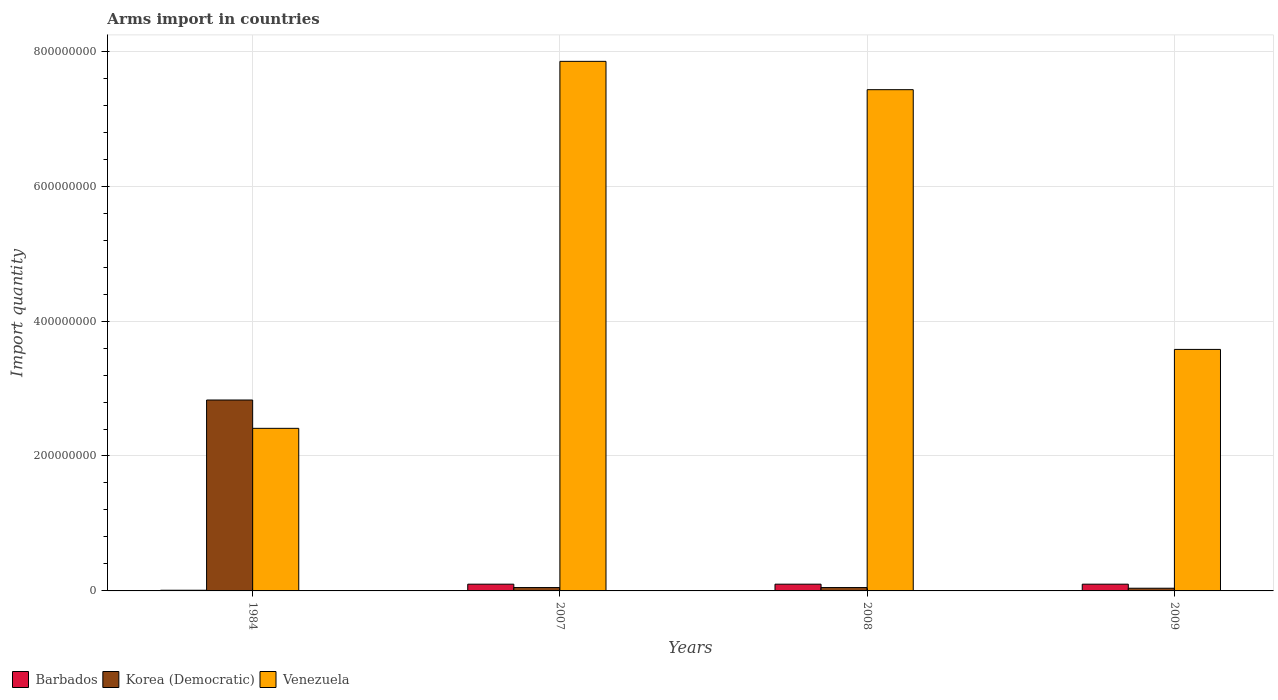Are the number of bars per tick equal to the number of legend labels?
Ensure brevity in your answer.  Yes. Are the number of bars on each tick of the X-axis equal?
Ensure brevity in your answer.  Yes. How many bars are there on the 4th tick from the left?
Your answer should be compact. 3. How many bars are there on the 2nd tick from the right?
Make the answer very short. 3. What is the label of the 2nd group of bars from the left?
Provide a short and direct response. 2007. In how many cases, is the number of bars for a given year not equal to the number of legend labels?
Make the answer very short. 0. What is the total arms import in Venezuela in 2007?
Your response must be concise. 7.85e+08. Across all years, what is the maximum total arms import in Venezuela?
Offer a terse response. 7.85e+08. In which year was the total arms import in Barbados minimum?
Your answer should be compact. 1984. What is the total total arms import in Barbados in the graph?
Give a very brief answer. 3.10e+07. What is the difference between the total arms import in Korea (Democratic) in 2007 and that in 2009?
Offer a very short reply. 1.00e+06. What is the difference between the total arms import in Venezuela in 2007 and the total arms import in Korea (Democratic) in 2009?
Provide a short and direct response. 7.81e+08. What is the average total arms import in Korea (Democratic) per year?
Offer a terse response. 7.42e+07. In the year 2008, what is the difference between the total arms import in Barbados and total arms import in Venezuela?
Keep it short and to the point. -7.33e+08. In how many years, is the total arms import in Barbados greater than 760000000?
Ensure brevity in your answer.  0. What is the ratio of the total arms import in Korea (Democratic) in 1984 to that in 2009?
Your response must be concise. 70.75. Is the total arms import in Barbados in 2008 less than that in 2009?
Ensure brevity in your answer.  No. Is the difference between the total arms import in Barbados in 1984 and 2009 greater than the difference between the total arms import in Venezuela in 1984 and 2009?
Give a very brief answer. Yes. What is the difference between the highest and the second highest total arms import in Venezuela?
Your answer should be very brief. 4.20e+07. What is the difference between the highest and the lowest total arms import in Venezuela?
Your answer should be very brief. 5.44e+08. In how many years, is the total arms import in Venezuela greater than the average total arms import in Venezuela taken over all years?
Your answer should be very brief. 2. Is the sum of the total arms import in Korea (Democratic) in 1984 and 2007 greater than the maximum total arms import in Venezuela across all years?
Your response must be concise. No. What does the 1st bar from the left in 1984 represents?
Provide a succinct answer. Barbados. What does the 2nd bar from the right in 2009 represents?
Your response must be concise. Korea (Democratic). How many bars are there?
Make the answer very short. 12. Are all the bars in the graph horizontal?
Your response must be concise. No. How many years are there in the graph?
Offer a terse response. 4. What is the difference between two consecutive major ticks on the Y-axis?
Your response must be concise. 2.00e+08. Does the graph contain grids?
Provide a succinct answer. Yes. How many legend labels are there?
Provide a succinct answer. 3. How are the legend labels stacked?
Your response must be concise. Horizontal. What is the title of the graph?
Ensure brevity in your answer.  Arms import in countries. What is the label or title of the Y-axis?
Keep it short and to the point. Import quantity. What is the Import quantity of Korea (Democratic) in 1984?
Ensure brevity in your answer.  2.83e+08. What is the Import quantity of Venezuela in 1984?
Your answer should be very brief. 2.41e+08. What is the Import quantity of Barbados in 2007?
Your answer should be very brief. 1.00e+07. What is the Import quantity in Korea (Democratic) in 2007?
Keep it short and to the point. 5.00e+06. What is the Import quantity of Venezuela in 2007?
Your answer should be very brief. 7.85e+08. What is the Import quantity in Barbados in 2008?
Your answer should be very brief. 1.00e+07. What is the Import quantity of Venezuela in 2008?
Your answer should be very brief. 7.43e+08. What is the Import quantity of Venezuela in 2009?
Provide a succinct answer. 3.58e+08. Across all years, what is the maximum Import quantity of Korea (Democratic)?
Ensure brevity in your answer.  2.83e+08. Across all years, what is the maximum Import quantity of Venezuela?
Offer a terse response. 7.85e+08. Across all years, what is the minimum Import quantity of Venezuela?
Offer a very short reply. 2.41e+08. What is the total Import quantity of Barbados in the graph?
Your answer should be very brief. 3.10e+07. What is the total Import quantity in Korea (Democratic) in the graph?
Ensure brevity in your answer.  2.97e+08. What is the total Import quantity in Venezuela in the graph?
Keep it short and to the point. 2.13e+09. What is the difference between the Import quantity of Barbados in 1984 and that in 2007?
Your answer should be very brief. -9.00e+06. What is the difference between the Import quantity of Korea (Democratic) in 1984 and that in 2007?
Offer a very short reply. 2.78e+08. What is the difference between the Import quantity of Venezuela in 1984 and that in 2007?
Your answer should be compact. -5.44e+08. What is the difference between the Import quantity in Barbados in 1984 and that in 2008?
Provide a succinct answer. -9.00e+06. What is the difference between the Import quantity in Korea (Democratic) in 1984 and that in 2008?
Your response must be concise. 2.78e+08. What is the difference between the Import quantity in Venezuela in 1984 and that in 2008?
Give a very brief answer. -5.02e+08. What is the difference between the Import quantity in Barbados in 1984 and that in 2009?
Ensure brevity in your answer.  -9.00e+06. What is the difference between the Import quantity in Korea (Democratic) in 1984 and that in 2009?
Provide a succinct answer. 2.79e+08. What is the difference between the Import quantity of Venezuela in 1984 and that in 2009?
Keep it short and to the point. -1.17e+08. What is the difference between the Import quantity in Venezuela in 2007 and that in 2008?
Offer a very short reply. 4.20e+07. What is the difference between the Import quantity of Barbados in 2007 and that in 2009?
Offer a very short reply. 0. What is the difference between the Import quantity of Venezuela in 2007 and that in 2009?
Provide a short and direct response. 4.27e+08. What is the difference between the Import quantity in Korea (Democratic) in 2008 and that in 2009?
Give a very brief answer. 1.00e+06. What is the difference between the Import quantity of Venezuela in 2008 and that in 2009?
Your answer should be compact. 3.85e+08. What is the difference between the Import quantity of Barbados in 1984 and the Import quantity of Korea (Democratic) in 2007?
Make the answer very short. -4.00e+06. What is the difference between the Import quantity in Barbados in 1984 and the Import quantity in Venezuela in 2007?
Offer a very short reply. -7.84e+08. What is the difference between the Import quantity in Korea (Democratic) in 1984 and the Import quantity in Venezuela in 2007?
Provide a short and direct response. -5.02e+08. What is the difference between the Import quantity of Barbados in 1984 and the Import quantity of Korea (Democratic) in 2008?
Give a very brief answer. -4.00e+06. What is the difference between the Import quantity of Barbados in 1984 and the Import quantity of Venezuela in 2008?
Make the answer very short. -7.42e+08. What is the difference between the Import quantity of Korea (Democratic) in 1984 and the Import quantity of Venezuela in 2008?
Give a very brief answer. -4.60e+08. What is the difference between the Import quantity of Barbados in 1984 and the Import quantity of Korea (Democratic) in 2009?
Keep it short and to the point. -3.00e+06. What is the difference between the Import quantity in Barbados in 1984 and the Import quantity in Venezuela in 2009?
Your response must be concise. -3.57e+08. What is the difference between the Import quantity in Korea (Democratic) in 1984 and the Import quantity in Venezuela in 2009?
Offer a terse response. -7.50e+07. What is the difference between the Import quantity in Barbados in 2007 and the Import quantity in Korea (Democratic) in 2008?
Your response must be concise. 5.00e+06. What is the difference between the Import quantity in Barbados in 2007 and the Import quantity in Venezuela in 2008?
Ensure brevity in your answer.  -7.33e+08. What is the difference between the Import quantity of Korea (Democratic) in 2007 and the Import quantity of Venezuela in 2008?
Provide a short and direct response. -7.38e+08. What is the difference between the Import quantity in Barbados in 2007 and the Import quantity in Korea (Democratic) in 2009?
Provide a succinct answer. 6.00e+06. What is the difference between the Import quantity of Barbados in 2007 and the Import quantity of Venezuela in 2009?
Keep it short and to the point. -3.48e+08. What is the difference between the Import quantity of Korea (Democratic) in 2007 and the Import quantity of Venezuela in 2009?
Your response must be concise. -3.53e+08. What is the difference between the Import quantity in Barbados in 2008 and the Import quantity in Korea (Democratic) in 2009?
Make the answer very short. 6.00e+06. What is the difference between the Import quantity in Barbados in 2008 and the Import quantity in Venezuela in 2009?
Keep it short and to the point. -3.48e+08. What is the difference between the Import quantity of Korea (Democratic) in 2008 and the Import quantity of Venezuela in 2009?
Offer a very short reply. -3.53e+08. What is the average Import quantity in Barbados per year?
Provide a succinct answer. 7.75e+06. What is the average Import quantity of Korea (Democratic) per year?
Offer a very short reply. 7.42e+07. What is the average Import quantity of Venezuela per year?
Give a very brief answer. 5.32e+08. In the year 1984, what is the difference between the Import quantity in Barbados and Import quantity in Korea (Democratic)?
Give a very brief answer. -2.82e+08. In the year 1984, what is the difference between the Import quantity in Barbados and Import quantity in Venezuela?
Offer a very short reply. -2.40e+08. In the year 1984, what is the difference between the Import quantity in Korea (Democratic) and Import quantity in Venezuela?
Your response must be concise. 4.20e+07. In the year 2007, what is the difference between the Import quantity of Barbados and Import quantity of Venezuela?
Your answer should be very brief. -7.75e+08. In the year 2007, what is the difference between the Import quantity of Korea (Democratic) and Import quantity of Venezuela?
Offer a very short reply. -7.80e+08. In the year 2008, what is the difference between the Import quantity in Barbados and Import quantity in Korea (Democratic)?
Provide a short and direct response. 5.00e+06. In the year 2008, what is the difference between the Import quantity in Barbados and Import quantity in Venezuela?
Provide a short and direct response. -7.33e+08. In the year 2008, what is the difference between the Import quantity of Korea (Democratic) and Import quantity of Venezuela?
Offer a terse response. -7.38e+08. In the year 2009, what is the difference between the Import quantity of Barbados and Import quantity of Korea (Democratic)?
Your answer should be compact. 6.00e+06. In the year 2009, what is the difference between the Import quantity of Barbados and Import quantity of Venezuela?
Keep it short and to the point. -3.48e+08. In the year 2009, what is the difference between the Import quantity of Korea (Democratic) and Import quantity of Venezuela?
Provide a short and direct response. -3.54e+08. What is the ratio of the Import quantity of Barbados in 1984 to that in 2007?
Provide a succinct answer. 0.1. What is the ratio of the Import quantity of Korea (Democratic) in 1984 to that in 2007?
Give a very brief answer. 56.6. What is the ratio of the Import quantity of Venezuela in 1984 to that in 2007?
Offer a very short reply. 0.31. What is the ratio of the Import quantity of Barbados in 1984 to that in 2008?
Provide a succinct answer. 0.1. What is the ratio of the Import quantity of Korea (Democratic) in 1984 to that in 2008?
Provide a succinct answer. 56.6. What is the ratio of the Import quantity of Venezuela in 1984 to that in 2008?
Give a very brief answer. 0.32. What is the ratio of the Import quantity in Korea (Democratic) in 1984 to that in 2009?
Your response must be concise. 70.75. What is the ratio of the Import quantity of Venezuela in 1984 to that in 2009?
Your answer should be compact. 0.67. What is the ratio of the Import quantity of Barbados in 2007 to that in 2008?
Provide a succinct answer. 1. What is the ratio of the Import quantity of Korea (Democratic) in 2007 to that in 2008?
Keep it short and to the point. 1. What is the ratio of the Import quantity in Venezuela in 2007 to that in 2008?
Your answer should be compact. 1.06. What is the ratio of the Import quantity in Korea (Democratic) in 2007 to that in 2009?
Ensure brevity in your answer.  1.25. What is the ratio of the Import quantity in Venezuela in 2007 to that in 2009?
Your response must be concise. 2.19. What is the ratio of the Import quantity of Korea (Democratic) in 2008 to that in 2009?
Keep it short and to the point. 1.25. What is the ratio of the Import quantity of Venezuela in 2008 to that in 2009?
Offer a terse response. 2.08. What is the difference between the highest and the second highest Import quantity in Barbados?
Your answer should be very brief. 0. What is the difference between the highest and the second highest Import quantity of Korea (Democratic)?
Offer a very short reply. 2.78e+08. What is the difference between the highest and the second highest Import quantity of Venezuela?
Your answer should be very brief. 4.20e+07. What is the difference between the highest and the lowest Import quantity in Barbados?
Give a very brief answer. 9.00e+06. What is the difference between the highest and the lowest Import quantity of Korea (Democratic)?
Give a very brief answer. 2.79e+08. What is the difference between the highest and the lowest Import quantity in Venezuela?
Offer a terse response. 5.44e+08. 